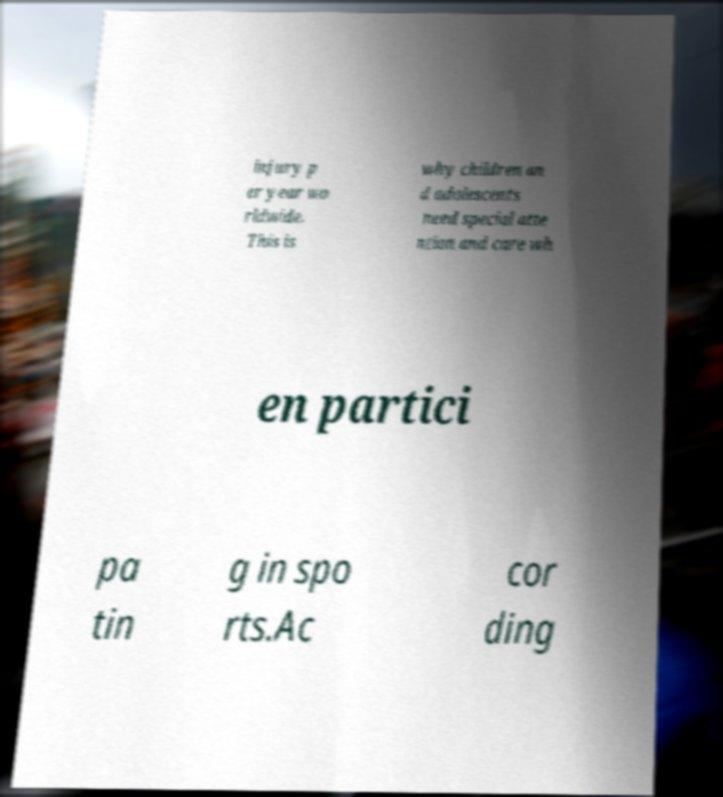There's text embedded in this image that I need extracted. Can you transcribe it verbatim? injury p er year wo rldwide. This is why children an d adolescents need special atte ntion and care wh en partici pa tin g in spo rts.Ac cor ding 